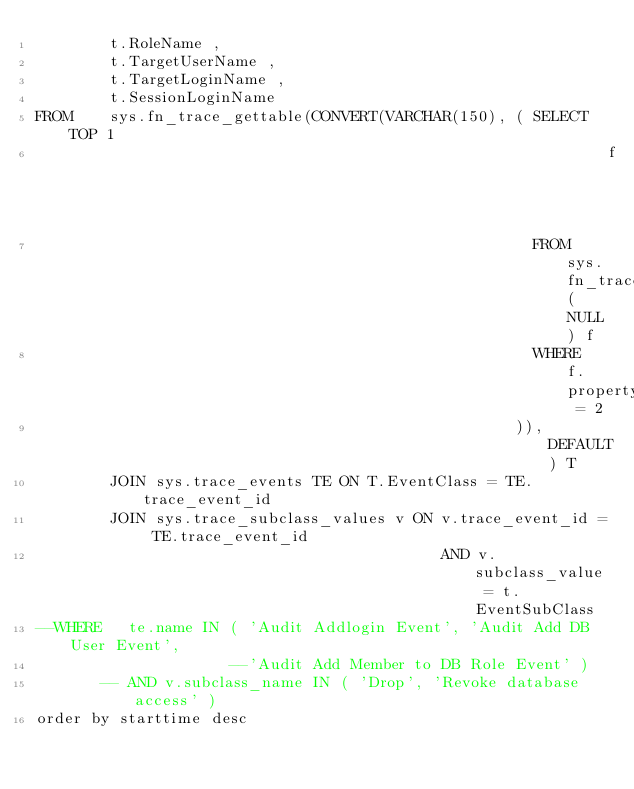Convert code to text. <code><loc_0><loc_0><loc_500><loc_500><_SQL_>        t.RoleName ,
        t.TargetUserName ,
        t.TargetLoginName ,
        t.SessionLoginName
FROM    sys.fn_trace_gettable(CONVERT(VARCHAR(150), ( SELECT TOP 1
                                                              f.[value]
                                                      FROM    sys.fn_trace_getinfo(NULL) f
                                                      WHERE   f.property = 2
                                                    )), DEFAULT) T
        JOIN sys.trace_events TE ON T.EventClass = TE.trace_event_id
        JOIN sys.trace_subclass_values v ON v.trace_event_id = TE.trace_event_id
                                            AND v.subclass_value = t.EventSubClass
--WHERE   te.name IN ( 'Audit Addlogin Event', 'Audit Add DB User Event',
                     --'Audit Add Member to DB Role Event' )
       -- AND v.subclass_name IN ( 'Drop', 'Revoke database access' )
order by starttime desc</code> 